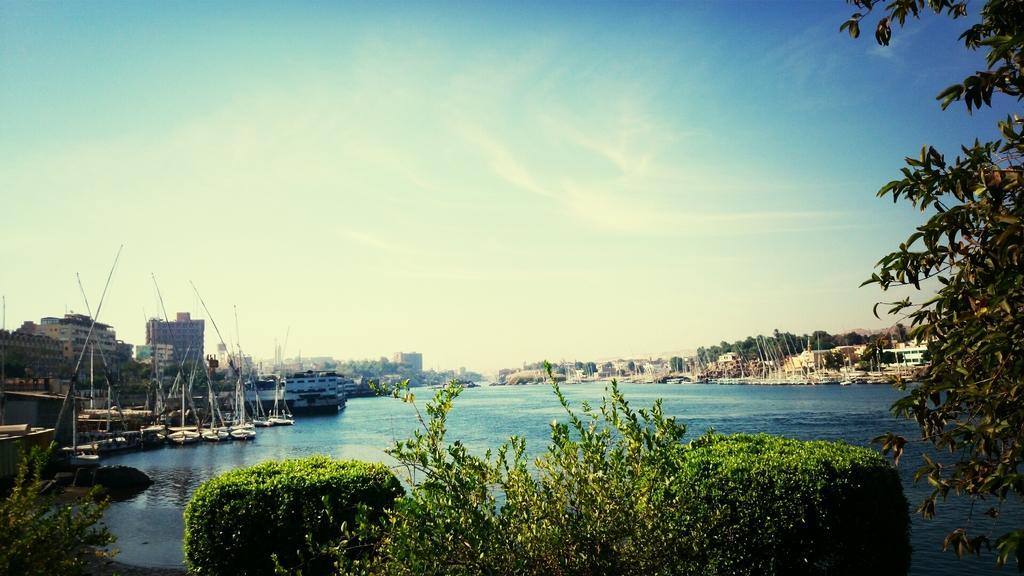Could you give a brief overview of what you see in this image? At the bottom of this image, there are plants and trees. In the background, there are boats on the water, there are buildings, trees and there are clouds in the blue sky. 